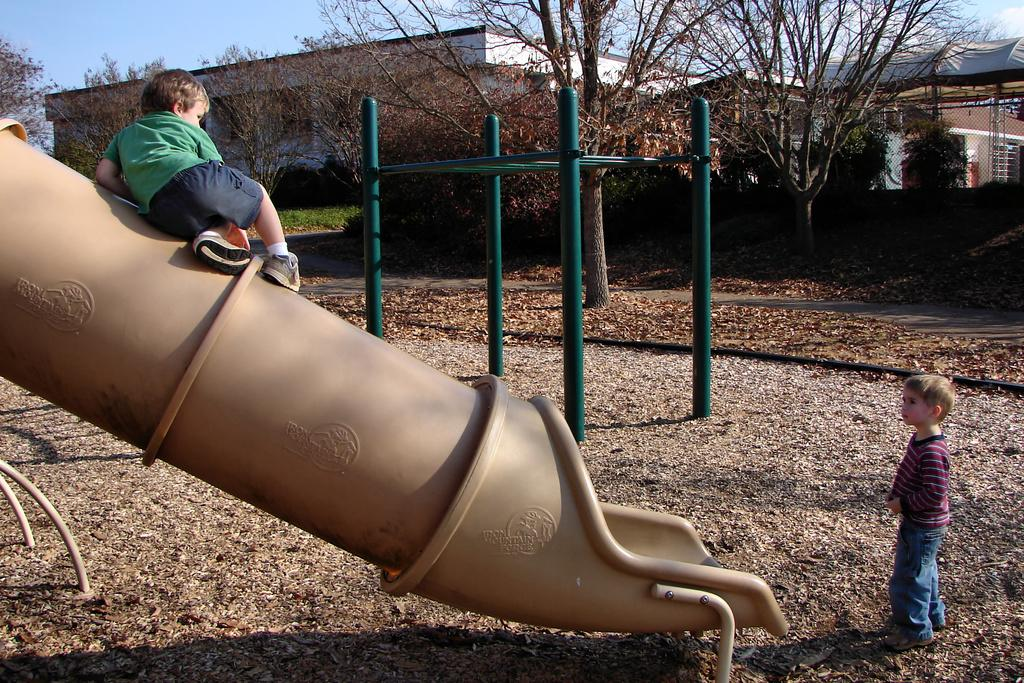How many children are in the image? There are two children in the image. What are the children wearing? The children are wearing clothes and shoes. What type of terrain is visible in the image? There is dry grass, grass, and a path in the image. What structures can be seen in the background? There are buildings and trees in the image. What is the color of the sky in the image? The sky is pale blue in the image. What type of army is depicted in the image? There is no army present in the image; it features two children and various landscape elements. What suggestion is being made by the children in the image? The image does not depict any specific suggestions being made by the children. 